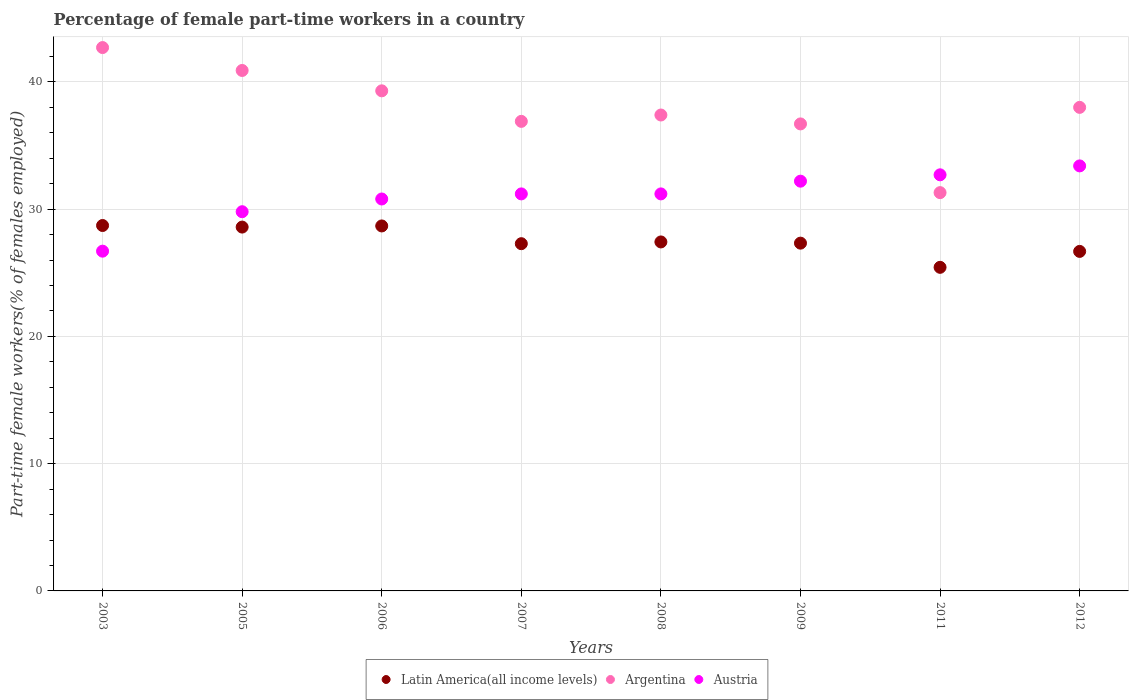What is the percentage of female part-time workers in Latin America(all income levels) in 2011?
Give a very brief answer. 25.43. Across all years, what is the maximum percentage of female part-time workers in Argentina?
Your response must be concise. 42.7. Across all years, what is the minimum percentage of female part-time workers in Austria?
Keep it short and to the point. 26.7. In which year was the percentage of female part-time workers in Argentina minimum?
Offer a terse response. 2011. What is the total percentage of female part-time workers in Latin America(all income levels) in the graph?
Your response must be concise. 220.14. What is the difference between the percentage of female part-time workers in Latin America(all income levels) in 2008 and that in 2009?
Offer a terse response. 0.1. What is the difference between the percentage of female part-time workers in Latin America(all income levels) in 2006 and the percentage of female part-time workers in Austria in 2009?
Offer a very short reply. -3.52. What is the average percentage of female part-time workers in Latin America(all income levels) per year?
Your response must be concise. 27.52. In the year 2006, what is the difference between the percentage of female part-time workers in Latin America(all income levels) and percentage of female part-time workers in Argentina?
Your answer should be compact. -10.62. What is the ratio of the percentage of female part-time workers in Latin America(all income levels) in 2009 to that in 2012?
Offer a very short reply. 1.02. Is the difference between the percentage of female part-time workers in Latin America(all income levels) in 2005 and 2009 greater than the difference between the percentage of female part-time workers in Argentina in 2005 and 2009?
Your answer should be compact. No. What is the difference between the highest and the second highest percentage of female part-time workers in Argentina?
Provide a succinct answer. 1.8. What is the difference between the highest and the lowest percentage of female part-time workers in Latin America(all income levels)?
Your response must be concise. 3.29. In how many years, is the percentage of female part-time workers in Argentina greater than the average percentage of female part-time workers in Argentina taken over all years?
Keep it short and to the point. 4. Is it the case that in every year, the sum of the percentage of female part-time workers in Latin America(all income levels) and percentage of female part-time workers in Argentina  is greater than the percentage of female part-time workers in Austria?
Offer a very short reply. Yes. Does the percentage of female part-time workers in Argentina monotonically increase over the years?
Make the answer very short. No. Is the percentage of female part-time workers in Austria strictly less than the percentage of female part-time workers in Argentina over the years?
Offer a very short reply. No. How many dotlines are there?
Keep it short and to the point. 3. Are the values on the major ticks of Y-axis written in scientific E-notation?
Provide a succinct answer. No. Does the graph contain any zero values?
Offer a terse response. No. Does the graph contain grids?
Offer a very short reply. Yes. What is the title of the graph?
Offer a very short reply. Percentage of female part-time workers in a country. Does "Vanuatu" appear as one of the legend labels in the graph?
Make the answer very short. No. What is the label or title of the Y-axis?
Provide a succinct answer. Part-time female workers(% of females employed). What is the Part-time female workers(% of females employed) of Latin America(all income levels) in 2003?
Offer a terse response. 28.72. What is the Part-time female workers(% of females employed) of Argentina in 2003?
Your answer should be compact. 42.7. What is the Part-time female workers(% of females employed) in Austria in 2003?
Provide a succinct answer. 26.7. What is the Part-time female workers(% of females employed) of Latin America(all income levels) in 2005?
Your response must be concise. 28.59. What is the Part-time female workers(% of females employed) in Argentina in 2005?
Ensure brevity in your answer.  40.9. What is the Part-time female workers(% of females employed) of Austria in 2005?
Give a very brief answer. 29.8. What is the Part-time female workers(% of females employed) in Latin America(all income levels) in 2006?
Your answer should be compact. 28.68. What is the Part-time female workers(% of females employed) in Argentina in 2006?
Offer a terse response. 39.3. What is the Part-time female workers(% of females employed) of Austria in 2006?
Your answer should be very brief. 30.8. What is the Part-time female workers(% of females employed) of Latin America(all income levels) in 2007?
Your answer should be compact. 27.29. What is the Part-time female workers(% of females employed) of Argentina in 2007?
Make the answer very short. 36.9. What is the Part-time female workers(% of females employed) in Austria in 2007?
Your answer should be compact. 31.2. What is the Part-time female workers(% of females employed) of Latin America(all income levels) in 2008?
Give a very brief answer. 27.42. What is the Part-time female workers(% of females employed) in Argentina in 2008?
Keep it short and to the point. 37.4. What is the Part-time female workers(% of females employed) of Austria in 2008?
Offer a terse response. 31.2. What is the Part-time female workers(% of females employed) of Latin America(all income levels) in 2009?
Your answer should be compact. 27.33. What is the Part-time female workers(% of females employed) of Argentina in 2009?
Your answer should be compact. 36.7. What is the Part-time female workers(% of females employed) of Austria in 2009?
Keep it short and to the point. 32.2. What is the Part-time female workers(% of females employed) of Latin America(all income levels) in 2011?
Offer a terse response. 25.43. What is the Part-time female workers(% of females employed) in Argentina in 2011?
Your response must be concise. 31.3. What is the Part-time female workers(% of females employed) of Austria in 2011?
Ensure brevity in your answer.  32.7. What is the Part-time female workers(% of females employed) in Latin America(all income levels) in 2012?
Your answer should be compact. 26.68. What is the Part-time female workers(% of females employed) of Argentina in 2012?
Provide a short and direct response. 38. What is the Part-time female workers(% of females employed) in Austria in 2012?
Offer a very short reply. 33.4. Across all years, what is the maximum Part-time female workers(% of females employed) of Latin America(all income levels)?
Keep it short and to the point. 28.72. Across all years, what is the maximum Part-time female workers(% of females employed) of Argentina?
Make the answer very short. 42.7. Across all years, what is the maximum Part-time female workers(% of females employed) in Austria?
Give a very brief answer. 33.4. Across all years, what is the minimum Part-time female workers(% of females employed) of Latin America(all income levels)?
Offer a very short reply. 25.43. Across all years, what is the minimum Part-time female workers(% of females employed) of Argentina?
Offer a terse response. 31.3. Across all years, what is the minimum Part-time female workers(% of females employed) in Austria?
Your answer should be compact. 26.7. What is the total Part-time female workers(% of females employed) of Latin America(all income levels) in the graph?
Ensure brevity in your answer.  220.14. What is the total Part-time female workers(% of females employed) of Argentina in the graph?
Provide a short and direct response. 303.2. What is the total Part-time female workers(% of females employed) in Austria in the graph?
Provide a succinct answer. 248. What is the difference between the Part-time female workers(% of females employed) in Latin America(all income levels) in 2003 and that in 2005?
Offer a terse response. 0.12. What is the difference between the Part-time female workers(% of females employed) in Austria in 2003 and that in 2005?
Your response must be concise. -3.1. What is the difference between the Part-time female workers(% of females employed) in Latin America(all income levels) in 2003 and that in 2006?
Make the answer very short. 0.03. What is the difference between the Part-time female workers(% of females employed) in Argentina in 2003 and that in 2006?
Make the answer very short. 3.4. What is the difference between the Part-time female workers(% of females employed) in Latin America(all income levels) in 2003 and that in 2007?
Your answer should be compact. 1.43. What is the difference between the Part-time female workers(% of females employed) in Argentina in 2003 and that in 2007?
Provide a succinct answer. 5.8. What is the difference between the Part-time female workers(% of females employed) in Latin America(all income levels) in 2003 and that in 2008?
Give a very brief answer. 1.29. What is the difference between the Part-time female workers(% of females employed) of Latin America(all income levels) in 2003 and that in 2009?
Offer a very short reply. 1.39. What is the difference between the Part-time female workers(% of females employed) of Argentina in 2003 and that in 2009?
Make the answer very short. 6. What is the difference between the Part-time female workers(% of females employed) in Latin America(all income levels) in 2003 and that in 2011?
Your answer should be compact. 3.29. What is the difference between the Part-time female workers(% of females employed) in Argentina in 2003 and that in 2011?
Provide a succinct answer. 11.4. What is the difference between the Part-time female workers(% of females employed) in Austria in 2003 and that in 2011?
Ensure brevity in your answer.  -6. What is the difference between the Part-time female workers(% of females employed) of Latin America(all income levels) in 2003 and that in 2012?
Your answer should be very brief. 2.03. What is the difference between the Part-time female workers(% of females employed) of Austria in 2003 and that in 2012?
Provide a succinct answer. -6.7. What is the difference between the Part-time female workers(% of females employed) of Latin America(all income levels) in 2005 and that in 2006?
Offer a terse response. -0.09. What is the difference between the Part-time female workers(% of females employed) of Latin America(all income levels) in 2005 and that in 2007?
Ensure brevity in your answer.  1.3. What is the difference between the Part-time female workers(% of females employed) of Austria in 2005 and that in 2007?
Offer a very short reply. -1.4. What is the difference between the Part-time female workers(% of females employed) of Latin America(all income levels) in 2005 and that in 2008?
Provide a short and direct response. 1.17. What is the difference between the Part-time female workers(% of females employed) of Argentina in 2005 and that in 2008?
Offer a very short reply. 3.5. What is the difference between the Part-time female workers(% of females employed) of Austria in 2005 and that in 2008?
Ensure brevity in your answer.  -1.4. What is the difference between the Part-time female workers(% of females employed) of Latin America(all income levels) in 2005 and that in 2009?
Your answer should be very brief. 1.26. What is the difference between the Part-time female workers(% of females employed) in Austria in 2005 and that in 2009?
Make the answer very short. -2.4. What is the difference between the Part-time female workers(% of females employed) of Latin America(all income levels) in 2005 and that in 2011?
Provide a short and direct response. 3.16. What is the difference between the Part-time female workers(% of females employed) in Latin America(all income levels) in 2005 and that in 2012?
Make the answer very short. 1.91. What is the difference between the Part-time female workers(% of females employed) of Latin America(all income levels) in 2006 and that in 2007?
Ensure brevity in your answer.  1.39. What is the difference between the Part-time female workers(% of females employed) of Argentina in 2006 and that in 2007?
Offer a very short reply. 2.4. What is the difference between the Part-time female workers(% of females employed) of Austria in 2006 and that in 2007?
Offer a very short reply. -0.4. What is the difference between the Part-time female workers(% of females employed) of Latin America(all income levels) in 2006 and that in 2008?
Your answer should be very brief. 1.26. What is the difference between the Part-time female workers(% of females employed) of Argentina in 2006 and that in 2008?
Provide a succinct answer. 1.9. What is the difference between the Part-time female workers(% of females employed) in Austria in 2006 and that in 2008?
Offer a very short reply. -0.4. What is the difference between the Part-time female workers(% of females employed) in Latin America(all income levels) in 2006 and that in 2009?
Give a very brief answer. 1.35. What is the difference between the Part-time female workers(% of females employed) in Latin America(all income levels) in 2006 and that in 2011?
Offer a terse response. 3.25. What is the difference between the Part-time female workers(% of females employed) in Argentina in 2006 and that in 2011?
Your response must be concise. 8. What is the difference between the Part-time female workers(% of females employed) in Latin America(all income levels) in 2006 and that in 2012?
Offer a very short reply. 2. What is the difference between the Part-time female workers(% of females employed) of Latin America(all income levels) in 2007 and that in 2008?
Your answer should be very brief. -0.14. What is the difference between the Part-time female workers(% of females employed) in Latin America(all income levels) in 2007 and that in 2009?
Ensure brevity in your answer.  -0.04. What is the difference between the Part-time female workers(% of females employed) of Argentina in 2007 and that in 2009?
Provide a short and direct response. 0.2. What is the difference between the Part-time female workers(% of females employed) in Latin America(all income levels) in 2007 and that in 2011?
Keep it short and to the point. 1.86. What is the difference between the Part-time female workers(% of females employed) of Argentina in 2007 and that in 2011?
Provide a succinct answer. 5.6. What is the difference between the Part-time female workers(% of females employed) of Austria in 2007 and that in 2011?
Ensure brevity in your answer.  -1.5. What is the difference between the Part-time female workers(% of females employed) of Latin America(all income levels) in 2007 and that in 2012?
Your response must be concise. 0.61. What is the difference between the Part-time female workers(% of females employed) of Austria in 2007 and that in 2012?
Ensure brevity in your answer.  -2.2. What is the difference between the Part-time female workers(% of females employed) of Latin America(all income levels) in 2008 and that in 2009?
Keep it short and to the point. 0.1. What is the difference between the Part-time female workers(% of females employed) of Argentina in 2008 and that in 2009?
Offer a terse response. 0.7. What is the difference between the Part-time female workers(% of females employed) in Austria in 2008 and that in 2009?
Your answer should be very brief. -1. What is the difference between the Part-time female workers(% of females employed) in Latin America(all income levels) in 2008 and that in 2011?
Your answer should be compact. 2. What is the difference between the Part-time female workers(% of females employed) in Argentina in 2008 and that in 2011?
Provide a short and direct response. 6.1. What is the difference between the Part-time female workers(% of females employed) in Latin America(all income levels) in 2008 and that in 2012?
Offer a very short reply. 0.74. What is the difference between the Part-time female workers(% of females employed) in Latin America(all income levels) in 2009 and that in 2011?
Provide a succinct answer. 1.9. What is the difference between the Part-time female workers(% of females employed) of Argentina in 2009 and that in 2011?
Provide a succinct answer. 5.4. What is the difference between the Part-time female workers(% of females employed) in Austria in 2009 and that in 2011?
Give a very brief answer. -0.5. What is the difference between the Part-time female workers(% of females employed) of Latin America(all income levels) in 2009 and that in 2012?
Offer a terse response. 0.65. What is the difference between the Part-time female workers(% of females employed) of Argentina in 2009 and that in 2012?
Offer a very short reply. -1.3. What is the difference between the Part-time female workers(% of females employed) in Austria in 2009 and that in 2012?
Your answer should be very brief. -1.2. What is the difference between the Part-time female workers(% of females employed) in Latin America(all income levels) in 2011 and that in 2012?
Provide a succinct answer. -1.25. What is the difference between the Part-time female workers(% of females employed) of Argentina in 2011 and that in 2012?
Provide a succinct answer. -6.7. What is the difference between the Part-time female workers(% of females employed) in Latin America(all income levels) in 2003 and the Part-time female workers(% of females employed) in Argentina in 2005?
Your answer should be very brief. -12.18. What is the difference between the Part-time female workers(% of females employed) of Latin America(all income levels) in 2003 and the Part-time female workers(% of females employed) of Austria in 2005?
Provide a succinct answer. -1.08. What is the difference between the Part-time female workers(% of females employed) in Latin America(all income levels) in 2003 and the Part-time female workers(% of females employed) in Argentina in 2006?
Your answer should be very brief. -10.58. What is the difference between the Part-time female workers(% of females employed) of Latin America(all income levels) in 2003 and the Part-time female workers(% of females employed) of Austria in 2006?
Make the answer very short. -2.08. What is the difference between the Part-time female workers(% of females employed) of Latin America(all income levels) in 2003 and the Part-time female workers(% of females employed) of Argentina in 2007?
Make the answer very short. -8.18. What is the difference between the Part-time female workers(% of females employed) of Latin America(all income levels) in 2003 and the Part-time female workers(% of females employed) of Austria in 2007?
Offer a very short reply. -2.48. What is the difference between the Part-time female workers(% of females employed) of Argentina in 2003 and the Part-time female workers(% of females employed) of Austria in 2007?
Your response must be concise. 11.5. What is the difference between the Part-time female workers(% of females employed) in Latin America(all income levels) in 2003 and the Part-time female workers(% of females employed) in Argentina in 2008?
Provide a succinct answer. -8.68. What is the difference between the Part-time female workers(% of females employed) in Latin America(all income levels) in 2003 and the Part-time female workers(% of females employed) in Austria in 2008?
Your answer should be very brief. -2.48. What is the difference between the Part-time female workers(% of females employed) in Latin America(all income levels) in 2003 and the Part-time female workers(% of females employed) in Argentina in 2009?
Keep it short and to the point. -7.98. What is the difference between the Part-time female workers(% of females employed) of Latin America(all income levels) in 2003 and the Part-time female workers(% of females employed) of Austria in 2009?
Ensure brevity in your answer.  -3.48. What is the difference between the Part-time female workers(% of females employed) in Argentina in 2003 and the Part-time female workers(% of females employed) in Austria in 2009?
Keep it short and to the point. 10.5. What is the difference between the Part-time female workers(% of females employed) of Latin America(all income levels) in 2003 and the Part-time female workers(% of females employed) of Argentina in 2011?
Make the answer very short. -2.58. What is the difference between the Part-time female workers(% of females employed) in Latin America(all income levels) in 2003 and the Part-time female workers(% of females employed) in Austria in 2011?
Make the answer very short. -3.98. What is the difference between the Part-time female workers(% of females employed) of Argentina in 2003 and the Part-time female workers(% of females employed) of Austria in 2011?
Offer a terse response. 10. What is the difference between the Part-time female workers(% of females employed) in Latin America(all income levels) in 2003 and the Part-time female workers(% of females employed) in Argentina in 2012?
Give a very brief answer. -9.28. What is the difference between the Part-time female workers(% of females employed) of Latin America(all income levels) in 2003 and the Part-time female workers(% of females employed) of Austria in 2012?
Your answer should be very brief. -4.68. What is the difference between the Part-time female workers(% of females employed) of Latin America(all income levels) in 2005 and the Part-time female workers(% of females employed) of Argentina in 2006?
Provide a succinct answer. -10.71. What is the difference between the Part-time female workers(% of females employed) of Latin America(all income levels) in 2005 and the Part-time female workers(% of females employed) of Austria in 2006?
Ensure brevity in your answer.  -2.21. What is the difference between the Part-time female workers(% of females employed) in Latin America(all income levels) in 2005 and the Part-time female workers(% of females employed) in Argentina in 2007?
Provide a succinct answer. -8.31. What is the difference between the Part-time female workers(% of females employed) in Latin America(all income levels) in 2005 and the Part-time female workers(% of females employed) in Austria in 2007?
Your answer should be very brief. -2.61. What is the difference between the Part-time female workers(% of females employed) in Latin America(all income levels) in 2005 and the Part-time female workers(% of females employed) in Argentina in 2008?
Offer a very short reply. -8.81. What is the difference between the Part-time female workers(% of females employed) of Latin America(all income levels) in 2005 and the Part-time female workers(% of females employed) of Austria in 2008?
Provide a succinct answer. -2.61. What is the difference between the Part-time female workers(% of females employed) in Latin America(all income levels) in 2005 and the Part-time female workers(% of females employed) in Argentina in 2009?
Give a very brief answer. -8.11. What is the difference between the Part-time female workers(% of females employed) of Latin America(all income levels) in 2005 and the Part-time female workers(% of females employed) of Austria in 2009?
Your answer should be very brief. -3.61. What is the difference between the Part-time female workers(% of females employed) in Argentina in 2005 and the Part-time female workers(% of females employed) in Austria in 2009?
Give a very brief answer. 8.7. What is the difference between the Part-time female workers(% of females employed) of Latin America(all income levels) in 2005 and the Part-time female workers(% of females employed) of Argentina in 2011?
Keep it short and to the point. -2.71. What is the difference between the Part-time female workers(% of females employed) of Latin America(all income levels) in 2005 and the Part-time female workers(% of females employed) of Austria in 2011?
Offer a terse response. -4.11. What is the difference between the Part-time female workers(% of females employed) in Latin America(all income levels) in 2005 and the Part-time female workers(% of females employed) in Argentina in 2012?
Ensure brevity in your answer.  -9.41. What is the difference between the Part-time female workers(% of females employed) in Latin America(all income levels) in 2005 and the Part-time female workers(% of females employed) in Austria in 2012?
Your response must be concise. -4.81. What is the difference between the Part-time female workers(% of females employed) of Argentina in 2005 and the Part-time female workers(% of females employed) of Austria in 2012?
Give a very brief answer. 7.5. What is the difference between the Part-time female workers(% of females employed) in Latin America(all income levels) in 2006 and the Part-time female workers(% of females employed) in Argentina in 2007?
Ensure brevity in your answer.  -8.22. What is the difference between the Part-time female workers(% of females employed) of Latin America(all income levels) in 2006 and the Part-time female workers(% of females employed) of Austria in 2007?
Your response must be concise. -2.52. What is the difference between the Part-time female workers(% of females employed) in Latin America(all income levels) in 2006 and the Part-time female workers(% of females employed) in Argentina in 2008?
Make the answer very short. -8.72. What is the difference between the Part-time female workers(% of females employed) in Latin America(all income levels) in 2006 and the Part-time female workers(% of females employed) in Austria in 2008?
Keep it short and to the point. -2.52. What is the difference between the Part-time female workers(% of females employed) in Argentina in 2006 and the Part-time female workers(% of females employed) in Austria in 2008?
Provide a short and direct response. 8.1. What is the difference between the Part-time female workers(% of females employed) of Latin America(all income levels) in 2006 and the Part-time female workers(% of females employed) of Argentina in 2009?
Ensure brevity in your answer.  -8.02. What is the difference between the Part-time female workers(% of females employed) of Latin America(all income levels) in 2006 and the Part-time female workers(% of females employed) of Austria in 2009?
Give a very brief answer. -3.52. What is the difference between the Part-time female workers(% of females employed) in Argentina in 2006 and the Part-time female workers(% of females employed) in Austria in 2009?
Offer a terse response. 7.1. What is the difference between the Part-time female workers(% of females employed) in Latin America(all income levels) in 2006 and the Part-time female workers(% of females employed) in Argentina in 2011?
Your answer should be compact. -2.62. What is the difference between the Part-time female workers(% of females employed) in Latin America(all income levels) in 2006 and the Part-time female workers(% of females employed) in Austria in 2011?
Your answer should be very brief. -4.02. What is the difference between the Part-time female workers(% of females employed) of Argentina in 2006 and the Part-time female workers(% of females employed) of Austria in 2011?
Offer a terse response. 6.6. What is the difference between the Part-time female workers(% of females employed) of Latin America(all income levels) in 2006 and the Part-time female workers(% of females employed) of Argentina in 2012?
Give a very brief answer. -9.32. What is the difference between the Part-time female workers(% of females employed) in Latin America(all income levels) in 2006 and the Part-time female workers(% of females employed) in Austria in 2012?
Give a very brief answer. -4.72. What is the difference between the Part-time female workers(% of females employed) in Argentina in 2006 and the Part-time female workers(% of females employed) in Austria in 2012?
Your answer should be compact. 5.9. What is the difference between the Part-time female workers(% of females employed) of Latin America(all income levels) in 2007 and the Part-time female workers(% of females employed) of Argentina in 2008?
Ensure brevity in your answer.  -10.11. What is the difference between the Part-time female workers(% of females employed) in Latin America(all income levels) in 2007 and the Part-time female workers(% of females employed) in Austria in 2008?
Provide a succinct answer. -3.91. What is the difference between the Part-time female workers(% of females employed) of Latin America(all income levels) in 2007 and the Part-time female workers(% of females employed) of Argentina in 2009?
Offer a very short reply. -9.41. What is the difference between the Part-time female workers(% of females employed) of Latin America(all income levels) in 2007 and the Part-time female workers(% of females employed) of Austria in 2009?
Your answer should be very brief. -4.91. What is the difference between the Part-time female workers(% of females employed) of Argentina in 2007 and the Part-time female workers(% of females employed) of Austria in 2009?
Give a very brief answer. 4.7. What is the difference between the Part-time female workers(% of females employed) of Latin America(all income levels) in 2007 and the Part-time female workers(% of females employed) of Argentina in 2011?
Your answer should be compact. -4.01. What is the difference between the Part-time female workers(% of females employed) of Latin America(all income levels) in 2007 and the Part-time female workers(% of females employed) of Austria in 2011?
Make the answer very short. -5.41. What is the difference between the Part-time female workers(% of females employed) of Argentina in 2007 and the Part-time female workers(% of females employed) of Austria in 2011?
Ensure brevity in your answer.  4.2. What is the difference between the Part-time female workers(% of females employed) of Latin America(all income levels) in 2007 and the Part-time female workers(% of females employed) of Argentina in 2012?
Ensure brevity in your answer.  -10.71. What is the difference between the Part-time female workers(% of females employed) of Latin America(all income levels) in 2007 and the Part-time female workers(% of females employed) of Austria in 2012?
Make the answer very short. -6.11. What is the difference between the Part-time female workers(% of females employed) of Argentina in 2007 and the Part-time female workers(% of females employed) of Austria in 2012?
Make the answer very short. 3.5. What is the difference between the Part-time female workers(% of females employed) in Latin America(all income levels) in 2008 and the Part-time female workers(% of females employed) in Argentina in 2009?
Your answer should be very brief. -9.28. What is the difference between the Part-time female workers(% of females employed) in Latin America(all income levels) in 2008 and the Part-time female workers(% of females employed) in Austria in 2009?
Provide a short and direct response. -4.78. What is the difference between the Part-time female workers(% of females employed) of Latin America(all income levels) in 2008 and the Part-time female workers(% of females employed) of Argentina in 2011?
Make the answer very short. -3.88. What is the difference between the Part-time female workers(% of females employed) in Latin America(all income levels) in 2008 and the Part-time female workers(% of females employed) in Austria in 2011?
Offer a very short reply. -5.28. What is the difference between the Part-time female workers(% of females employed) of Latin America(all income levels) in 2008 and the Part-time female workers(% of females employed) of Argentina in 2012?
Ensure brevity in your answer.  -10.58. What is the difference between the Part-time female workers(% of females employed) of Latin America(all income levels) in 2008 and the Part-time female workers(% of females employed) of Austria in 2012?
Ensure brevity in your answer.  -5.98. What is the difference between the Part-time female workers(% of females employed) in Argentina in 2008 and the Part-time female workers(% of females employed) in Austria in 2012?
Provide a succinct answer. 4. What is the difference between the Part-time female workers(% of females employed) in Latin America(all income levels) in 2009 and the Part-time female workers(% of females employed) in Argentina in 2011?
Offer a terse response. -3.97. What is the difference between the Part-time female workers(% of females employed) of Latin America(all income levels) in 2009 and the Part-time female workers(% of females employed) of Austria in 2011?
Offer a terse response. -5.37. What is the difference between the Part-time female workers(% of females employed) in Latin America(all income levels) in 2009 and the Part-time female workers(% of females employed) in Argentina in 2012?
Your response must be concise. -10.67. What is the difference between the Part-time female workers(% of females employed) of Latin America(all income levels) in 2009 and the Part-time female workers(% of females employed) of Austria in 2012?
Give a very brief answer. -6.07. What is the difference between the Part-time female workers(% of females employed) in Latin America(all income levels) in 2011 and the Part-time female workers(% of females employed) in Argentina in 2012?
Keep it short and to the point. -12.57. What is the difference between the Part-time female workers(% of females employed) of Latin America(all income levels) in 2011 and the Part-time female workers(% of females employed) of Austria in 2012?
Offer a very short reply. -7.97. What is the difference between the Part-time female workers(% of females employed) of Argentina in 2011 and the Part-time female workers(% of females employed) of Austria in 2012?
Give a very brief answer. -2.1. What is the average Part-time female workers(% of females employed) of Latin America(all income levels) per year?
Your response must be concise. 27.52. What is the average Part-time female workers(% of females employed) in Argentina per year?
Keep it short and to the point. 37.9. What is the average Part-time female workers(% of females employed) in Austria per year?
Ensure brevity in your answer.  31. In the year 2003, what is the difference between the Part-time female workers(% of females employed) in Latin America(all income levels) and Part-time female workers(% of females employed) in Argentina?
Ensure brevity in your answer.  -13.98. In the year 2003, what is the difference between the Part-time female workers(% of females employed) of Latin America(all income levels) and Part-time female workers(% of females employed) of Austria?
Make the answer very short. 2.02. In the year 2005, what is the difference between the Part-time female workers(% of females employed) in Latin America(all income levels) and Part-time female workers(% of females employed) in Argentina?
Ensure brevity in your answer.  -12.31. In the year 2005, what is the difference between the Part-time female workers(% of females employed) of Latin America(all income levels) and Part-time female workers(% of females employed) of Austria?
Make the answer very short. -1.21. In the year 2006, what is the difference between the Part-time female workers(% of females employed) of Latin America(all income levels) and Part-time female workers(% of females employed) of Argentina?
Your answer should be compact. -10.62. In the year 2006, what is the difference between the Part-time female workers(% of females employed) of Latin America(all income levels) and Part-time female workers(% of females employed) of Austria?
Offer a terse response. -2.12. In the year 2006, what is the difference between the Part-time female workers(% of females employed) in Argentina and Part-time female workers(% of females employed) in Austria?
Your answer should be very brief. 8.5. In the year 2007, what is the difference between the Part-time female workers(% of females employed) in Latin America(all income levels) and Part-time female workers(% of females employed) in Argentina?
Offer a terse response. -9.61. In the year 2007, what is the difference between the Part-time female workers(% of females employed) of Latin America(all income levels) and Part-time female workers(% of females employed) of Austria?
Ensure brevity in your answer.  -3.91. In the year 2007, what is the difference between the Part-time female workers(% of females employed) of Argentina and Part-time female workers(% of females employed) of Austria?
Make the answer very short. 5.7. In the year 2008, what is the difference between the Part-time female workers(% of females employed) of Latin America(all income levels) and Part-time female workers(% of females employed) of Argentina?
Ensure brevity in your answer.  -9.98. In the year 2008, what is the difference between the Part-time female workers(% of females employed) of Latin America(all income levels) and Part-time female workers(% of females employed) of Austria?
Make the answer very short. -3.78. In the year 2008, what is the difference between the Part-time female workers(% of females employed) in Argentina and Part-time female workers(% of females employed) in Austria?
Provide a short and direct response. 6.2. In the year 2009, what is the difference between the Part-time female workers(% of females employed) in Latin America(all income levels) and Part-time female workers(% of females employed) in Argentina?
Offer a very short reply. -9.37. In the year 2009, what is the difference between the Part-time female workers(% of females employed) of Latin America(all income levels) and Part-time female workers(% of females employed) of Austria?
Your answer should be compact. -4.87. In the year 2011, what is the difference between the Part-time female workers(% of females employed) in Latin America(all income levels) and Part-time female workers(% of females employed) in Argentina?
Provide a short and direct response. -5.87. In the year 2011, what is the difference between the Part-time female workers(% of females employed) of Latin America(all income levels) and Part-time female workers(% of females employed) of Austria?
Offer a very short reply. -7.27. In the year 2012, what is the difference between the Part-time female workers(% of females employed) of Latin America(all income levels) and Part-time female workers(% of females employed) of Argentina?
Make the answer very short. -11.32. In the year 2012, what is the difference between the Part-time female workers(% of females employed) in Latin America(all income levels) and Part-time female workers(% of females employed) in Austria?
Offer a terse response. -6.72. In the year 2012, what is the difference between the Part-time female workers(% of females employed) of Argentina and Part-time female workers(% of females employed) of Austria?
Your answer should be very brief. 4.6. What is the ratio of the Part-time female workers(% of females employed) in Latin America(all income levels) in 2003 to that in 2005?
Your answer should be compact. 1. What is the ratio of the Part-time female workers(% of females employed) of Argentina in 2003 to that in 2005?
Your response must be concise. 1.04. What is the ratio of the Part-time female workers(% of females employed) in Austria in 2003 to that in 2005?
Make the answer very short. 0.9. What is the ratio of the Part-time female workers(% of females employed) of Latin America(all income levels) in 2003 to that in 2006?
Keep it short and to the point. 1. What is the ratio of the Part-time female workers(% of females employed) in Argentina in 2003 to that in 2006?
Provide a succinct answer. 1.09. What is the ratio of the Part-time female workers(% of females employed) in Austria in 2003 to that in 2006?
Provide a short and direct response. 0.87. What is the ratio of the Part-time female workers(% of females employed) in Latin America(all income levels) in 2003 to that in 2007?
Provide a short and direct response. 1.05. What is the ratio of the Part-time female workers(% of females employed) of Argentina in 2003 to that in 2007?
Ensure brevity in your answer.  1.16. What is the ratio of the Part-time female workers(% of females employed) in Austria in 2003 to that in 2007?
Offer a terse response. 0.86. What is the ratio of the Part-time female workers(% of females employed) in Latin America(all income levels) in 2003 to that in 2008?
Make the answer very short. 1.05. What is the ratio of the Part-time female workers(% of females employed) of Argentina in 2003 to that in 2008?
Ensure brevity in your answer.  1.14. What is the ratio of the Part-time female workers(% of females employed) of Austria in 2003 to that in 2008?
Provide a succinct answer. 0.86. What is the ratio of the Part-time female workers(% of females employed) in Latin America(all income levels) in 2003 to that in 2009?
Provide a short and direct response. 1.05. What is the ratio of the Part-time female workers(% of females employed) of Argentina in 2003 to that in 2009?
Give a very brief answer. 1.16. What is the ratio of the Part-time female workers(% of females employed) of Austria in 2003 to that in 2009?
Provide a succinct answer. 0.83. What is the ratio of the Part-time female workers(% of females employed) in Latin America(all income levels) in 2003 to that in 2011?
Make the answer very short. 1.13. What is the ratio of the Part-time female workers(% of females employed) of Argentina in 2003 to that in 2011?
Your answer should be compact. 1.36. What is the ratio of the Part-time female workers(% of females employed) in Austria in 2003 to that in 2011?
Make the answer very short. 0.82. What is the ratio of the Part-time female workers(% of females employed) in Latin America(all income levels) in 2003 to that in 2012?
Give a very brief answer. 1.08. What is the ratio of the Part-time female workers(% of females employed) in Argentina in 2003 to that in 2012?
Provide a short and direct response. 1.12. What is the ratio of the Part-time female workers(% of females employed) in Austria in 2003 to that in 2012?
Provide a short and direct response. 0.8. What is the ratio of the Part-time female workers(% of females employed) of Latin America(all income levels) in 2005 to that in 2006?
Provide a short and direct response. 1. What is the ratio of the Part-time female workers(% of females employed) in Argentina in 2005 to that in 2006?
Your response must be concise. 1.04. What is the ratio of the Part-time female workers(% of females employed) in Austria in 2005 to that in 2006?
Offer a very short reply. 0.97. What is the ratio of the Part-time female workers(% of females employed) in Latin America(all income levels) in 2005 to that in 2007?
Keep it short and to the point. 1.05. What is the ratio of the Part-time female workers(% of females employed) in Argentina in 2005 to that in 2007?
Your answer should be compact. 1.11. What is the ratio of the Part-time female workers(% of females employed) in Austria in 2005 to that in 2007?
Make the answer very short. 0.96. What is the ratio of the Part-time female workers(% of females employed) of Latin America(all income levels) in 2005 to that in 2008?
Ensure brevity in your answer.  1.04. What is the ratio of the Part-time female workers(% of females employed) in Argentina in 2005 to that in 2008?
Provide a short and direct response. 1.09. What is the ratio of the Part-time female workers(% of females employed) in Austria in 2005 to that in 2008?
Your answer should be very brief. 0.96. What is the ratio of the Part-time female workers(% of females employed) in Latin America(all income levels) in 2005 to that in 2009?
Your answer should be compact. 1.05. What is the ratio of the Part-time female workers(% of females employed) in Argentina in 2005 to that in 2009?
Provide a succinct answer. 1.11. What is the ratio of the Part-time female workers(% of females employed) of Austria in 2005 to that in 2009?
Provide a succinct answer. 0.93. What is the ratio of the Part-time female workers(% of females employed) of Latin America(all income levels) in 2005 to that in 2011?
Keep it short and to the point. 1.12. What is the ratio of the Part-time female workers(% of females employed) in Argentina in 2005 to that in 2011?
Your response must be concise. 1.31. What is the ratio of the Part-time female workers(% of females employed) of Austria in 2005 to that in 2011?
Provide a succinct answer. 0.91. What is the ratio of the Part-time female workers(% of females employed) of Latin America(all income levels) in 2005 to that in 2012?
Keep it short and to the point. 1.07. What is the ratio of the Part-time female workers(% of females employed) of Argentina in 2005 to that in 2012?
Make the answer very short. 1.08. What is the ratio of the Part-time female workers(% of females employed) in Austria in 2005 to that in 2012?
Provide a succinct answer. 0.89. What is the ratio of the Part-time female workers(% of females employed) in Latin America(all income levels) in 2006 to that in 2007?
Your answer should be compact. 1.05. What is the ratio of the Part-time female workers(% of females employed) of Argentina in 2006 to that in 2007?
Offer a very short reply. 1.06. What is the ratio of the Part-time female workers(% of females employed) in Austria in 2006 to that in 2007?
Offer a terse response. 0.99. What is the ratio of the Part-time female workers(% of females employed) in Latin America(all income levels) in 2006 to that in 2008?
Your response must be concise. 1.05. What is the ratio of the Part-time female workers(% of females employed) of Argentina in 2006 to that in 2008?
Your response must be concise. 1.05. What is the ratio of the Part-time female workers(% of females employed) of Austria in 2006 to that in 2008?
Your answer should be very brief. 0.99. What is the ratio of the Part-time female workers(% of females employed) of Latin America(all income levels) in 2006 to that in 2009?
Your answer should be compact. 1.05. What is the ratio of the Part-time female workers(% of females employed) in Argentina in 2006 to that in 2009?
Your answer should be compact. 1.07. What is the ratio of the Part-time female workers(% of females employed) in Austria in 2006 to that in 2009?
Your answer should be compact. 0.96. What is the ratio of the Part-time female workers(% of females employed) in Latin America(all income levels) in 2006 to that in 2011?
Your response must be concise. 1.13. What is the ratio of the Part-time female workers(% of females employed) of Argentina in 2006 to that in 2011?
Offer a terse response. 1.26. What is the ratio of the Part-time female workers(% of females employed) in Austria in 2006 to that in 2011?
Provide a short and direct response. 0.94. What is the ratio of the Part-time female workers(% of females employed) of Latin America(all income levels) in 2006 to that in 2012?
Ensure brevity in your answer.  1.07. What is the ratio of the Part-time female workers(% of females employed) in Argentina in 2006 to that in 2012?
Your answer should be compact. 1.03. What is the ratio of the Part-time female workers(% of females employed) in Austria in 2006 to that in 2012?
Make the answer very short. 0.92. What is the ratio of the Part-time female workers(% of females employed) of Latin America(all income levels) in 2007 to that in 2008?
Keep it short and to the point. 0.99. What is the ratio of the Part-time female workers(% of females employed) of Argentina in 2007 to that in 2008?
Your response must be concise. 0.99. What is the ratio of the Part-time female workers(% of females employed) in Latin America(all income levels) in 2007 to that in 2009?
Give a very brief answer. 1. What is the ratio of the Part-time female workers(% of females employed) of Argentina in 2007 to that in 2009?
Your answer should be very brief. 1.01. What is the ratio of the Part-time female workers(% of females employed) in Austria in 2007 to that in 2009?
Provide a short and direct response. 0.97. What is the ratio of the Part-time female workers(% of females employed) in Latin America(all income levels) in 2007 to that in 2011?
Your answer should be compact. 1.07. What is the ratio of the Part-time female workers(% of females employed) in Argentina in 2007 to that in 2011?
Give a very brief answer. 1.18. What is the ratio of the Part-time female workers(% of females employed) of Austria in 2007 to that in 2011?
Offer a very short reply. 0.95. What is the ratio of the Part-time female workers(% of females employed) of Latin America(all income levels) in 2007 to that in 2012?
Ensure brevity in your answer.  1.02. What is the ratio of the Part-time female workers(% of females employed) in Argentina in 2007 to that in 2012?
Your response must be concise. 0.97. What is the ratio of the Part-time female workers(% of females employed) in Austria in 2007 to that in 2012?
Make the answer very short. 0.93. What is the ratio of the Part-time female workers(% of females employed) of Latin America(all income levels) in 2008 to that in 2009?
Provide a succinct answer. 1. What is the ratio of the Part-time female workers(% of females employed) in Argentina in 2008 to that in 2009?
Give a very brief answer. 1.02. What is the ratio of the Part-time female workers(% of females employed) in Austria in 2008 to that in 2009?
Your answer should be very brief. 0.97. What is the ratio of the Part-time female workers(% of females employed) of Latin America(all income levels) in 2008 to that in 2011?
Keep it short and to the point. 1.08. What is the ratio of the Part-time female workers(% of females employed) in Argentina in 2008 to that in 2011?
Provide a short and direct response. 1.19. What is the ratio of the Part-time female workers(% of females employed) of Austria in 2008 to that in 2011?
Offer a terse response. 0.95. What is the ratio of the Part-time female workers(% of females employed) of Latin America(all income levels) in 2008 to that in 2012?
Your answer should be very brief. 1.03. What is the ratio of the Part-time female workers(% of females employed) of Argentina in 2008 to that in 2012?
Offer a very short reply. 0.98. What is the ratio of the Part-time female workers(% of females employed) of Austria in 2008 to that in 2012?
Offer a terse response. 0.93. What is the ratio of the Part-time female workers(% of females employed) of Latin America(all income levels) in 2009 to that in 2011?
Provide a succinct answer. 1.07. What is the ratio of the Part-time female workers(% of females employed) in Argentina in 2009 to that in 2011?
Make the answer very short. 1.17. What is the ratio of the Part-time female workers(% of females employed) in Austria in 2009 to that in 2011?
Ensure brevity in your answer.  0.98. What is the ratio of the Part-time female workers(% of females employed) in Latin America(all income levels) in 2009 to that in 2012?
Offer a very short reply. 1.02. What is the ratio of the Part-time female workers(% of females employed) of Argentina in 2009 to that in 2012?
Make the answer very short. 0.97. What is the ratio of the Part-time female workers(% of females employed) in Austria in 2009 to that in 2012?
Ensure brevity in your answer.  0.96. What is the ratio of the Part-time female workers(% of females employed) in Latin America(all income levels) in 2011 to that in 2012?
Make the answer very short. 0.95. What is the ratio of the Part-time female workers(% of females employed) in Argentina in 2011 to that in 2012?
Offer a very short reply. 0.82. What is the ratio of the Part-time female workers(% of females employed) in Austria in 2011 to that in 2012?
Your answer should be compact. 0.98. What is the difference between the highest and the second highest Part-time female workers(% of females employed) of Latin America(all income levels)?
Offer a terse response. 0.03. What is the difference between the highest and the lowest Part-time female workers(% of females employed) in Latin America(all income levels)?
Provide a short and direct response. 3.29. What is the difference between the highest and the lowest Part-time female workers(% of females employed) in Austria?
Offer a very short reply. 6.7. 